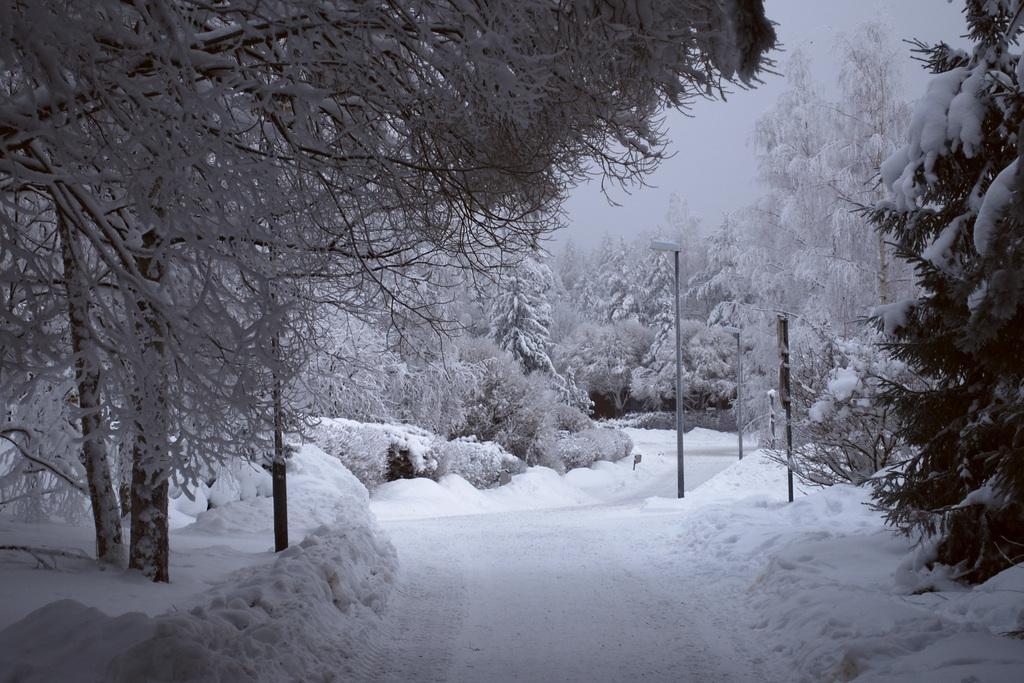Can you describe this image briefly? In this picture I can observe some snow on the land. On either sides of the picture I can observe some trees. There is a path in the middle of the picture. 